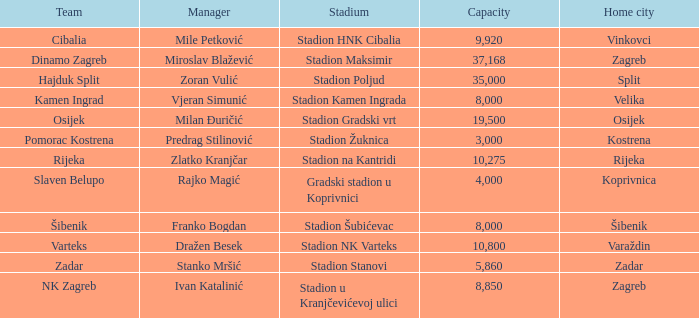What team that has a Home city of Zadar? Zadar. 